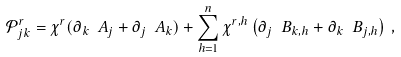<formula> <loc_0><loc_0><loc_500><loc_500>\mathcal { P } _ { j k } ^ { r } = \chi ^ { r } ( \partial _ { k } \ A _ { j } + \partial _ { j } \ A _ { k } ) + \sum _ { h = 1 } ^ { n } \chi ^ { r , h } \left ( \partial _ { j } \ B _ { k , h } + \partial _ { k } \ B _ { j , h } \right ) \, ,</formula> 